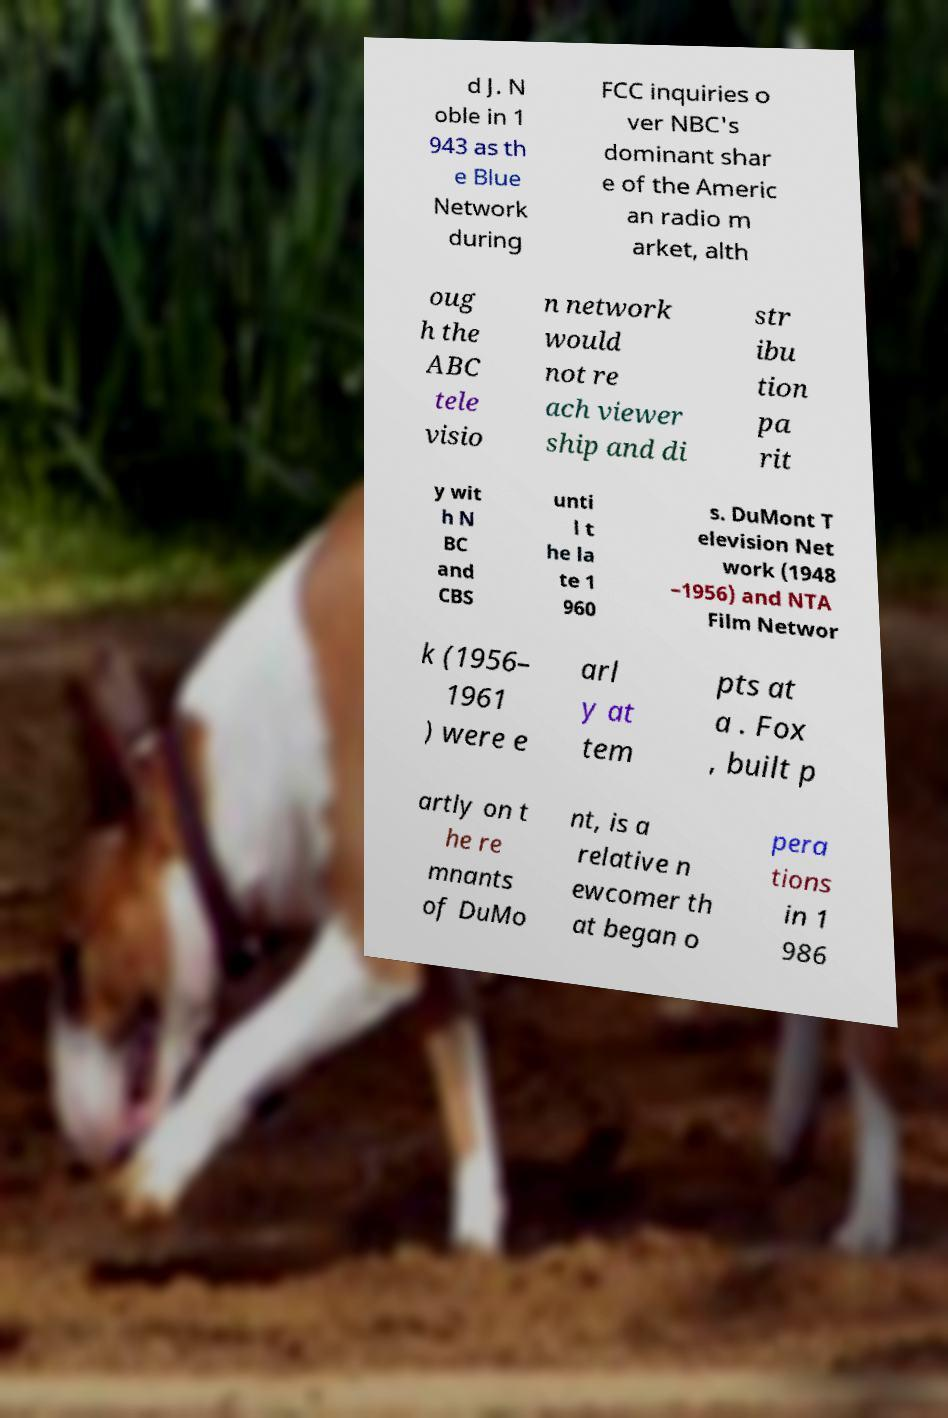Can you read and provide the text displayed in the image?This photo seems to have some interesting text. Can you extract and type it out for me? d J. N oble in 1 943 as th e Blue Network during FCC inquiries o ver NBC's dominant shar e of the Americ an radio m arket, alth oug h the ABC tele visio n network would not re ach viewer ship and di str ibu tion pa rit y wit h N BC and CBS unti l t he la te 1 960 s. DuMont T elevision Net work (1948 –1956) and NTA Film Networ k (1956– 1961 ) were e arl y at tem pts at a . Fox , built p artly on t he re mnants of DuMo nt, is a relative n ewcomer th at began o pera tions in 1 986 